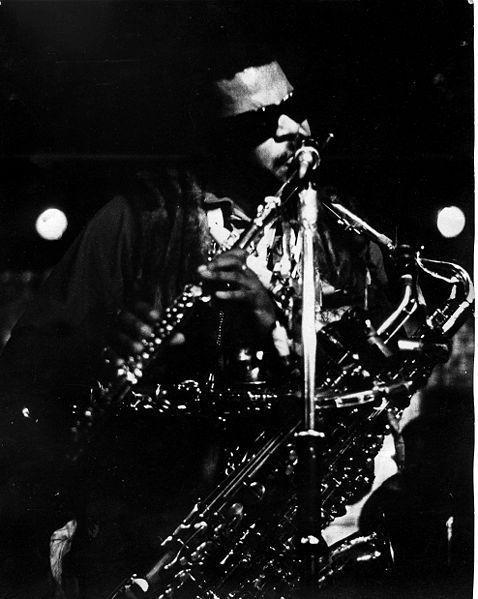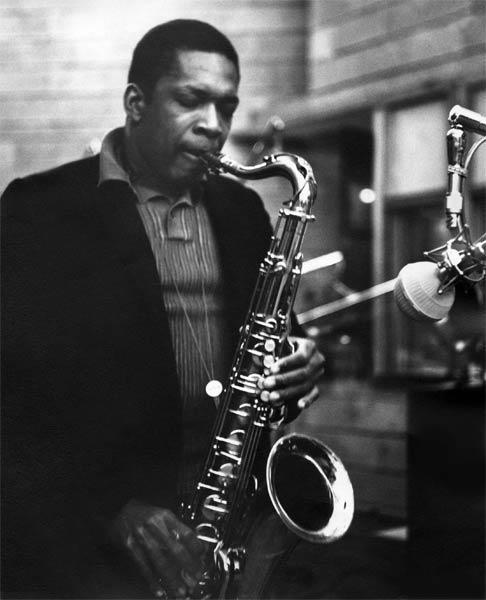The first image is the image on the left, the second image is the image on the right. For the images displayed, is the sentence "In one of the pictures a musician is wearing a hat." factually correct? Answer yes or no. No. The first image is the image on the left, the second image is the image on the right. For the images shown, is this caption "An image shows a non-black man with bare forearms playing the sax." true? Answer yes or no. No. 